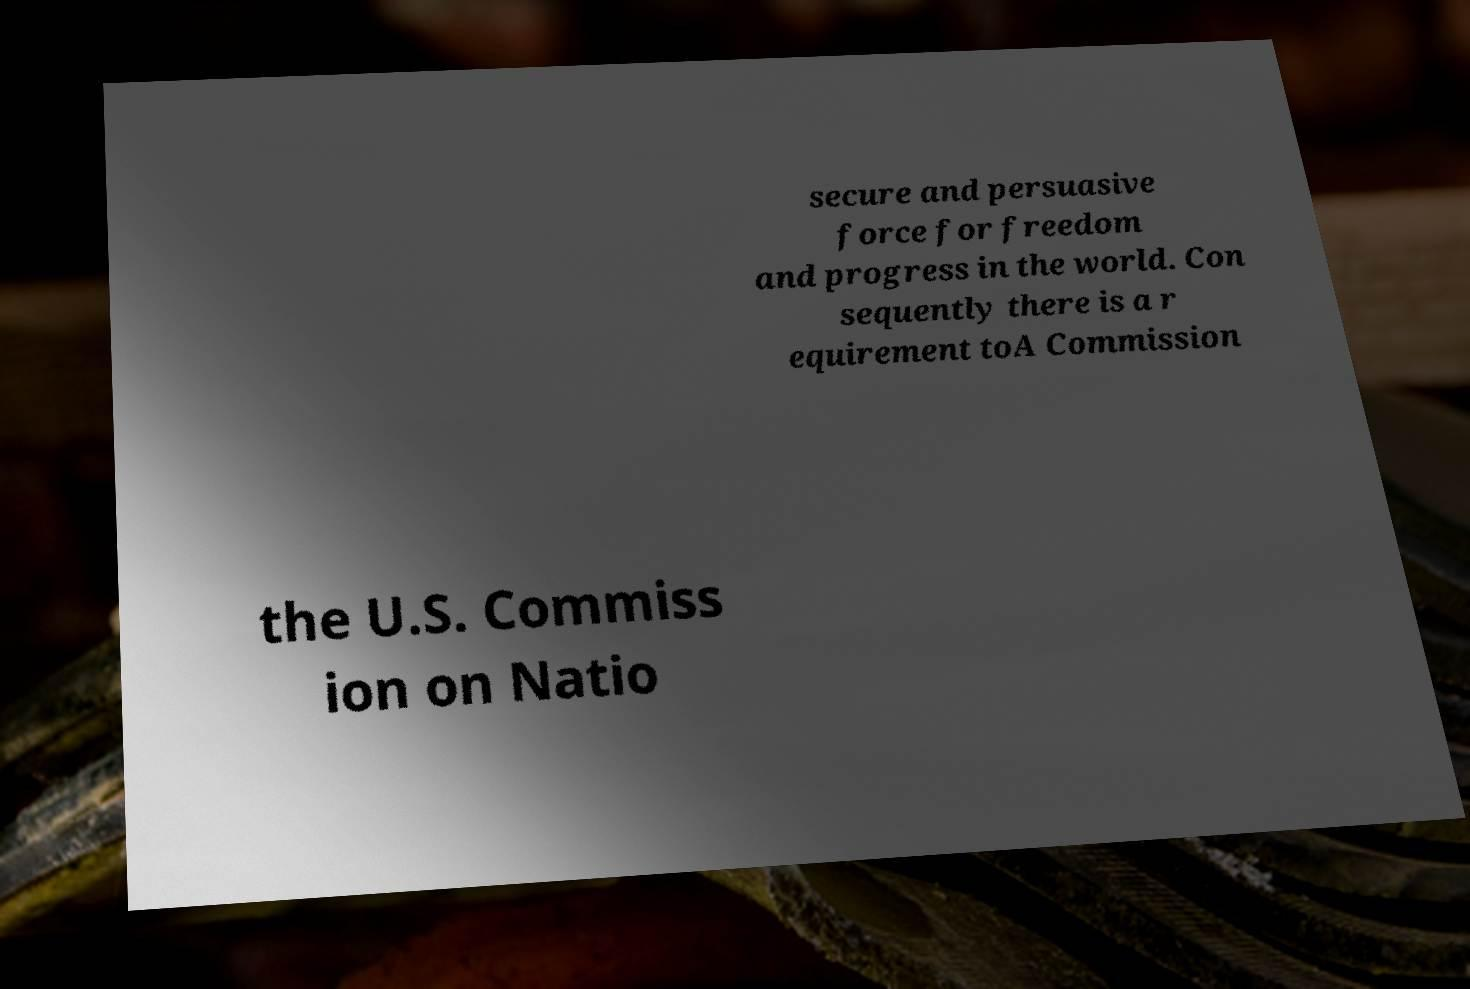For documentation purposes, I need the text within this image transcribed. Could you provide that? secure and persuasive force for freedom and progress in the world. Con sequently there is a r equirement toA Commission the U.S. Commiss ion on Natio 